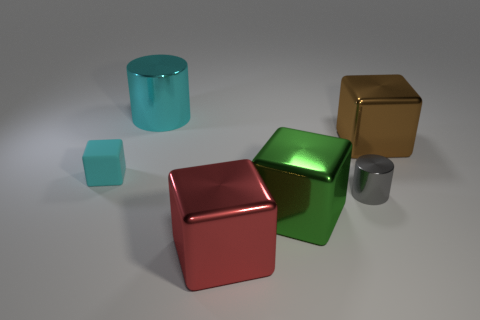What number of large cyan rubber objects are there? 0 